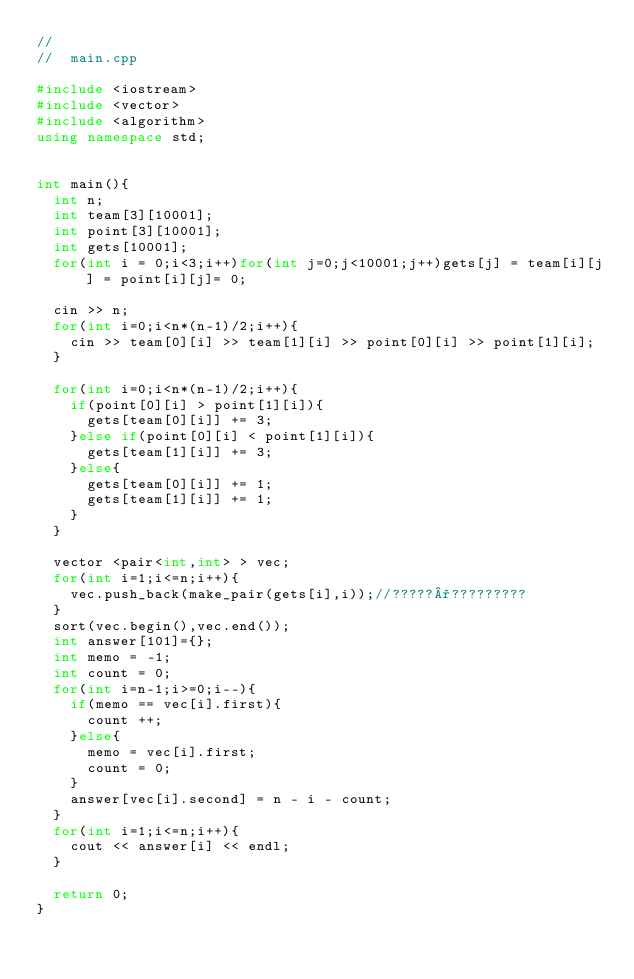<code> <loc_0><loc_0><loc_500><loc_500><_C++_>//
//  main.cpp

#include <iostream>
#include <vector>
#include <algorithm>
using namespace std;


int main(){	
	int n;
	int team[3][10001];
	int point[3][10001];
	int gets[10001];
	for(int i = 0;i<3;i++)for(int j=0;j<10001;j++)gets[j] = team[i][j] = point[i][j]= 0;
	
	cin >> n;
	for(int i=0;i<n*(n-1)/2;i++){
		cin >> team[0][i] >> team[1][i] >> point[0][i] >> point[1][i];
	}
	
	for(int i=0;i<n*(n-1)/2;i++){
		if(point[0][i] > point[1][i]){
			gets[team[0][i]] += 3;
		}else if(point[0][i] < point[1][i]){
			gets[team[1][i]] += 3;
		}else{
			gets[team[0][i]] += 1;
			gets[team[1][i]] += 1;
		}
	}
	
	vector <pair<int,int> > vec;
	for(int i=1;i<=n;i++){
		vec.push_back(make_pair(gets[i],i));//?????°?????????
	}
	sort(vec.begin(),vec.end());
	int answer[101]={};
	int memo = -1;
	int count = 0;
	for(int i=n-1;i>=0;i--){
		if(memo == vec[i].first){
			count ++;
		}else{
			memo = vec[i].first;
			count = 0;
		}
		answer[vec[i].second] = n - i - count;
	}
	for(int i=1;i<=n;i++){
		cout << answer[i] << endl;
	}
	
	return 0;
}</code> 